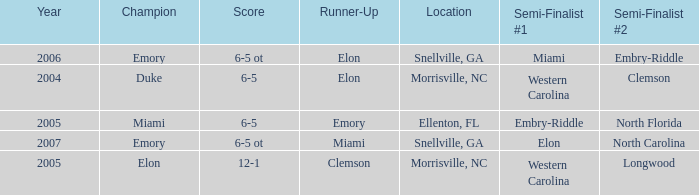When Embry-Riddle made it to the first semi finalist slot, list all the runners up. Emory. 